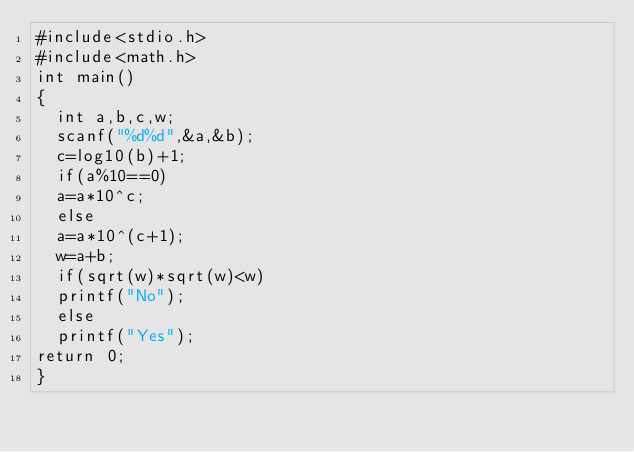Convert code to text. <code><loc_0><loc_0><loc_500><loc_500><_C_>#include<stdio.h>
#include<math.h>
int main()
{
	int a,b,c,w;
	scanf("%d%d",&a,&b);
	c=log10(b)+1;
	if(a%10==0)
	a=a*10^c;
	else
	a=a*10^(c+1);
	w=a+b;
	if(sqrt(w)*sqrt(w)<w)
	printf("No");
	else
	printf("Yes");
return 0;
}</code> 